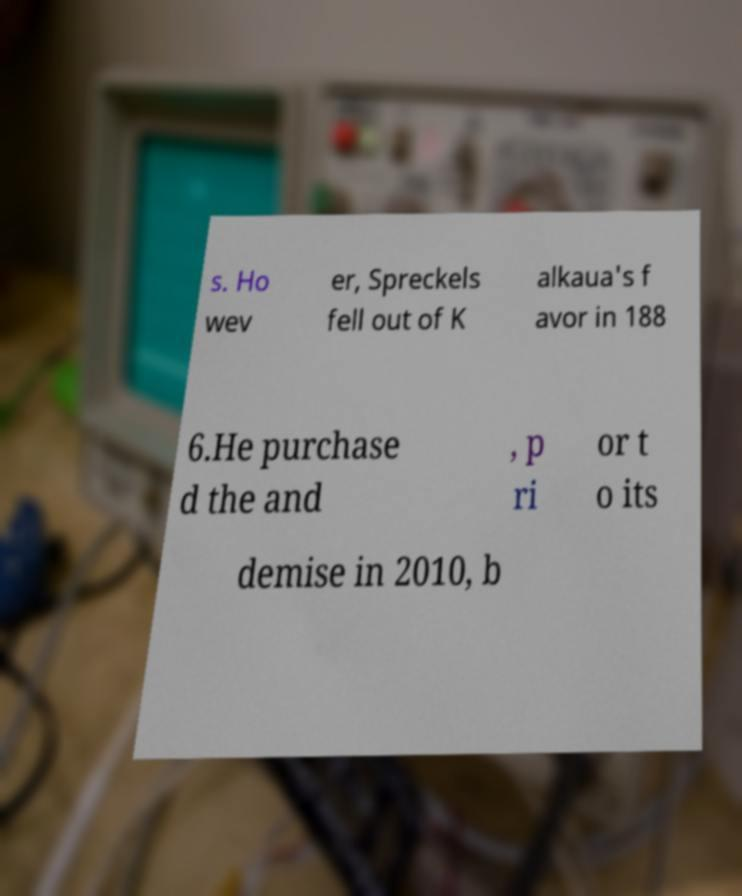I need the written content from this picture converted into text. Can you do that? s. Ho wev er, Spreckels fell out of K alkaua's f avor in 188 6.He purchase d the and , p ri or t o its demise in 2010, b 